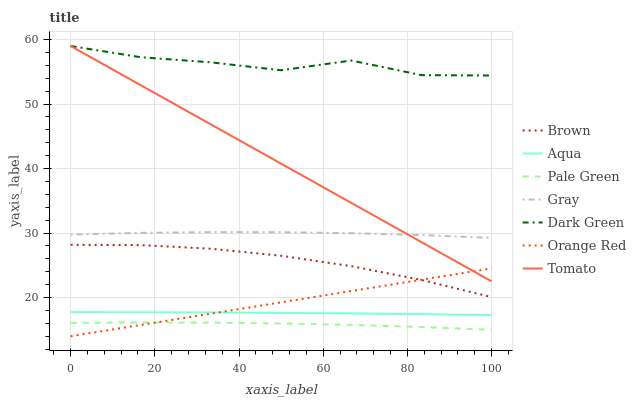Does Pale Green have the minimum area under the curve?
Answer yes or no. Yes. Does Dark Green have the maximum area under the curve?
Answer yes or no. Yes. Does Brown have the minimum area under the curve?
Answer yes or no. No. Does Brown have the maximum area under the curve?
Answer yes or no. No. Is Tomato the smoothest?
Answer yes or no. Yes. Is Dark Green the roughest?
Answer yes or no. Yes. Is Brown the smoothest?
Answer yes or no. No. Is Brown the roughest?
Answer yes or no. No. Does Orange Red have the lowest value?
Answer yes or no. Yes. Does Brown have the lowest value?
Answer yes or no. No. Does Dark Green have the highest value?
Answer yes or no. Yes. Does Brown have the highest value?
Answer yes or no. No. Is Pale Green less than Brown?
Answer yes or no. Yes. Is Gray greater than Aqua?
Answer yes or no. Yes. Does Tomato intersect Orange Red?
Answer yes or no. Yes. Is Tomato less than Orange Red?
Answer yes or no. No. Is Tomato greater than Orange Red?
Answer yes or no. No. Does Pale Green intersect Brown?
Answer yes or no. No. 